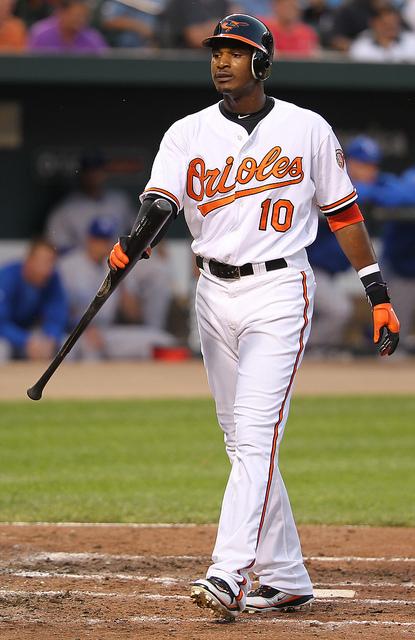What position is this?
Answer briefly. Batter. What town is this player's team based in?
Quick response, please. Baltimore. What team is the batter on?
Concise answer only. Orioles. What is the name of the team?
Answer briefly. Orioles. What number is on the batter's uniform?
Keep it brief. 10. What number is on his jersey?
Quick response, please. 10. Is this person probably being paid for this job?
Give a very brief answer. Yes. 